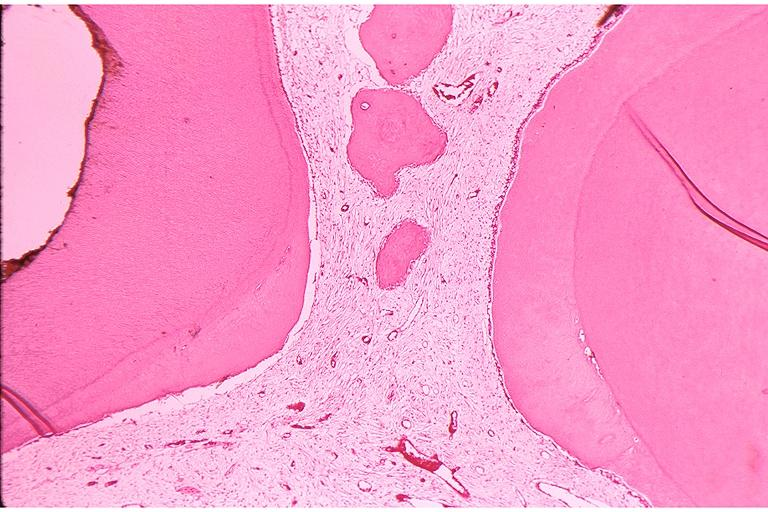does this image show secondary dentin and pulp calcification?
Answer the question using a single word or phrase. Yes 